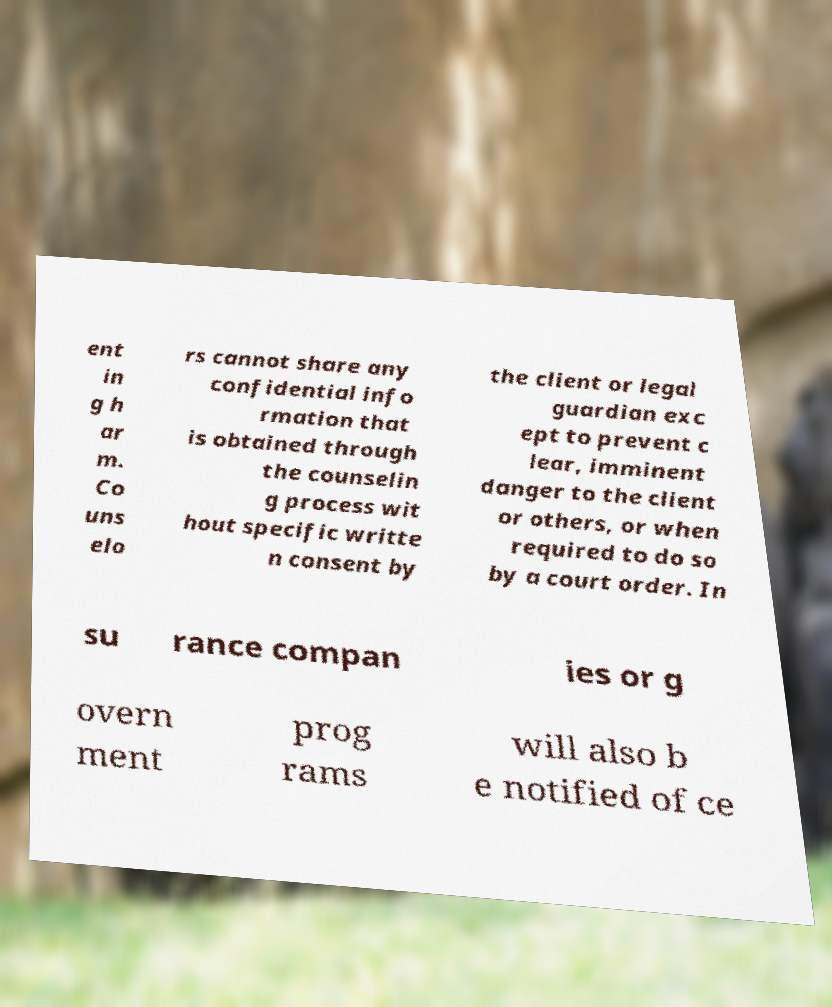Please read and relay the text visible in this image. What does it say? ent in g h ar m. Co uns elo rs cannot share any confidential info rmation that is obtained through the counselin g process wit hout specific writte n consent by the client or legal guardian exc ept to prevent c lear, imminent danger to the client or others, or when required to do so by a court order. In su rance compan ies or g overn ment prog rams will also b e notified of ce 